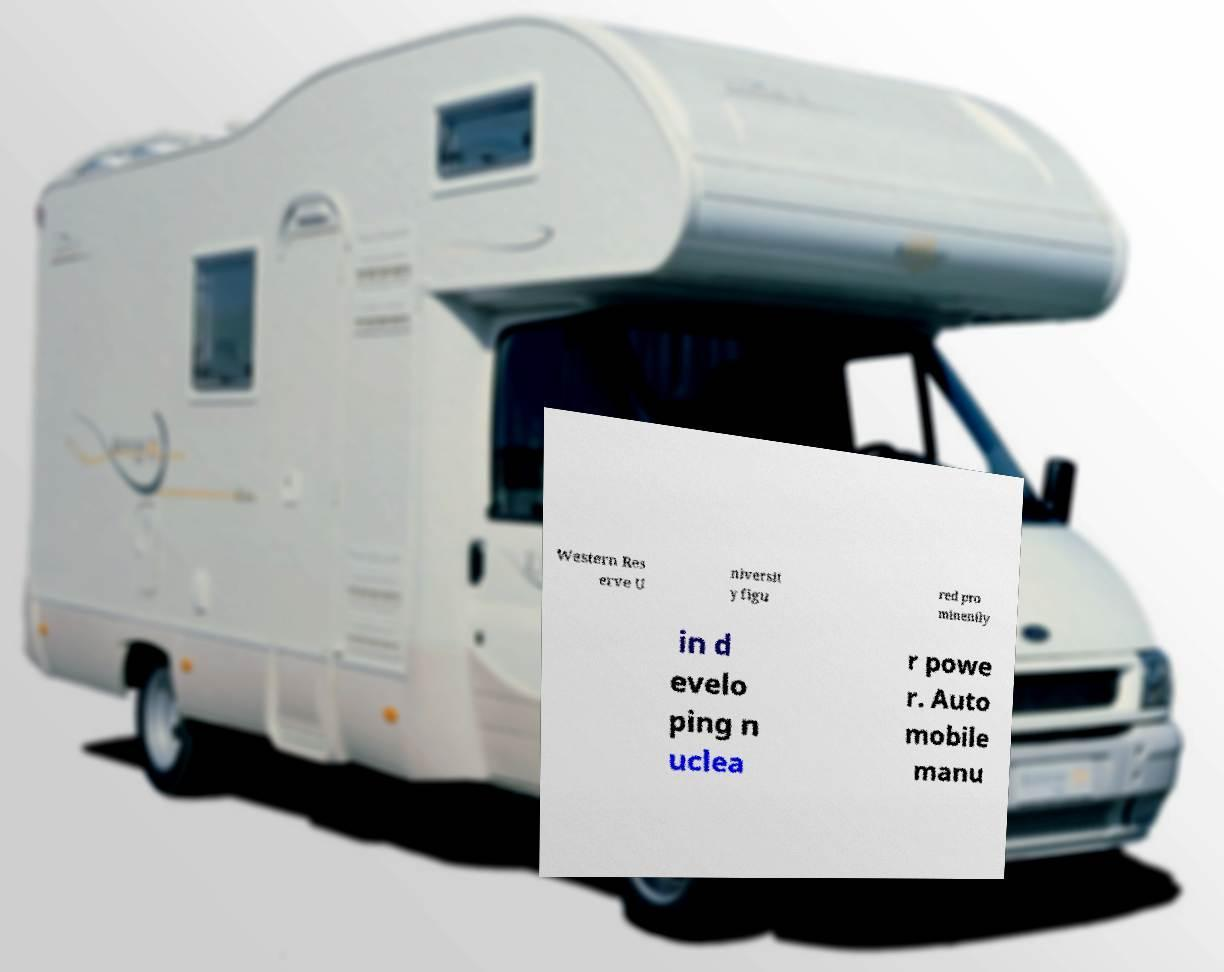Can you read and provide the text displayed in the image?This photo seems to have some interesting text. Can you extract and type it out for me? Western Res erve U niversit y figu red pro minently in d evelo ping n uclea r powe r. Auto mobile manu 